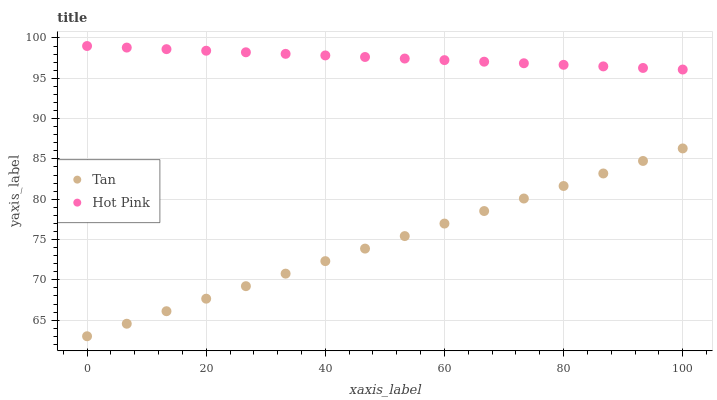Does Tan have the minimum area under the curve?
Answer yes or no. Yes. Does Hot Pink have the maximum area under the curve?
Answer yes or no. Yes. Does Hot Pink have the minimum area under the curve?
Answer yes or no. No. Is Hot Pink the smoothest?
Answer yes or no. Yes. Is Tan the roughest?
Answer yes or no. Yes. Is Hot Pink the roughest?
Answer yes or no. No. Does Tan have the lowest value?
Answer yes or no. Yes. Does Hot Pink have the lowest value?
Answer yes or no. No. Does Hot Pink have the highest value?
Answer yes or no. Yes. Is Tan less than Hot Pink?
Answer yes or no. Yes. Is Hot Pink greater than Tan?
Answer yes or no. Yes. Does Tan intersect Hot Pink?
Answer yes or no. No. 